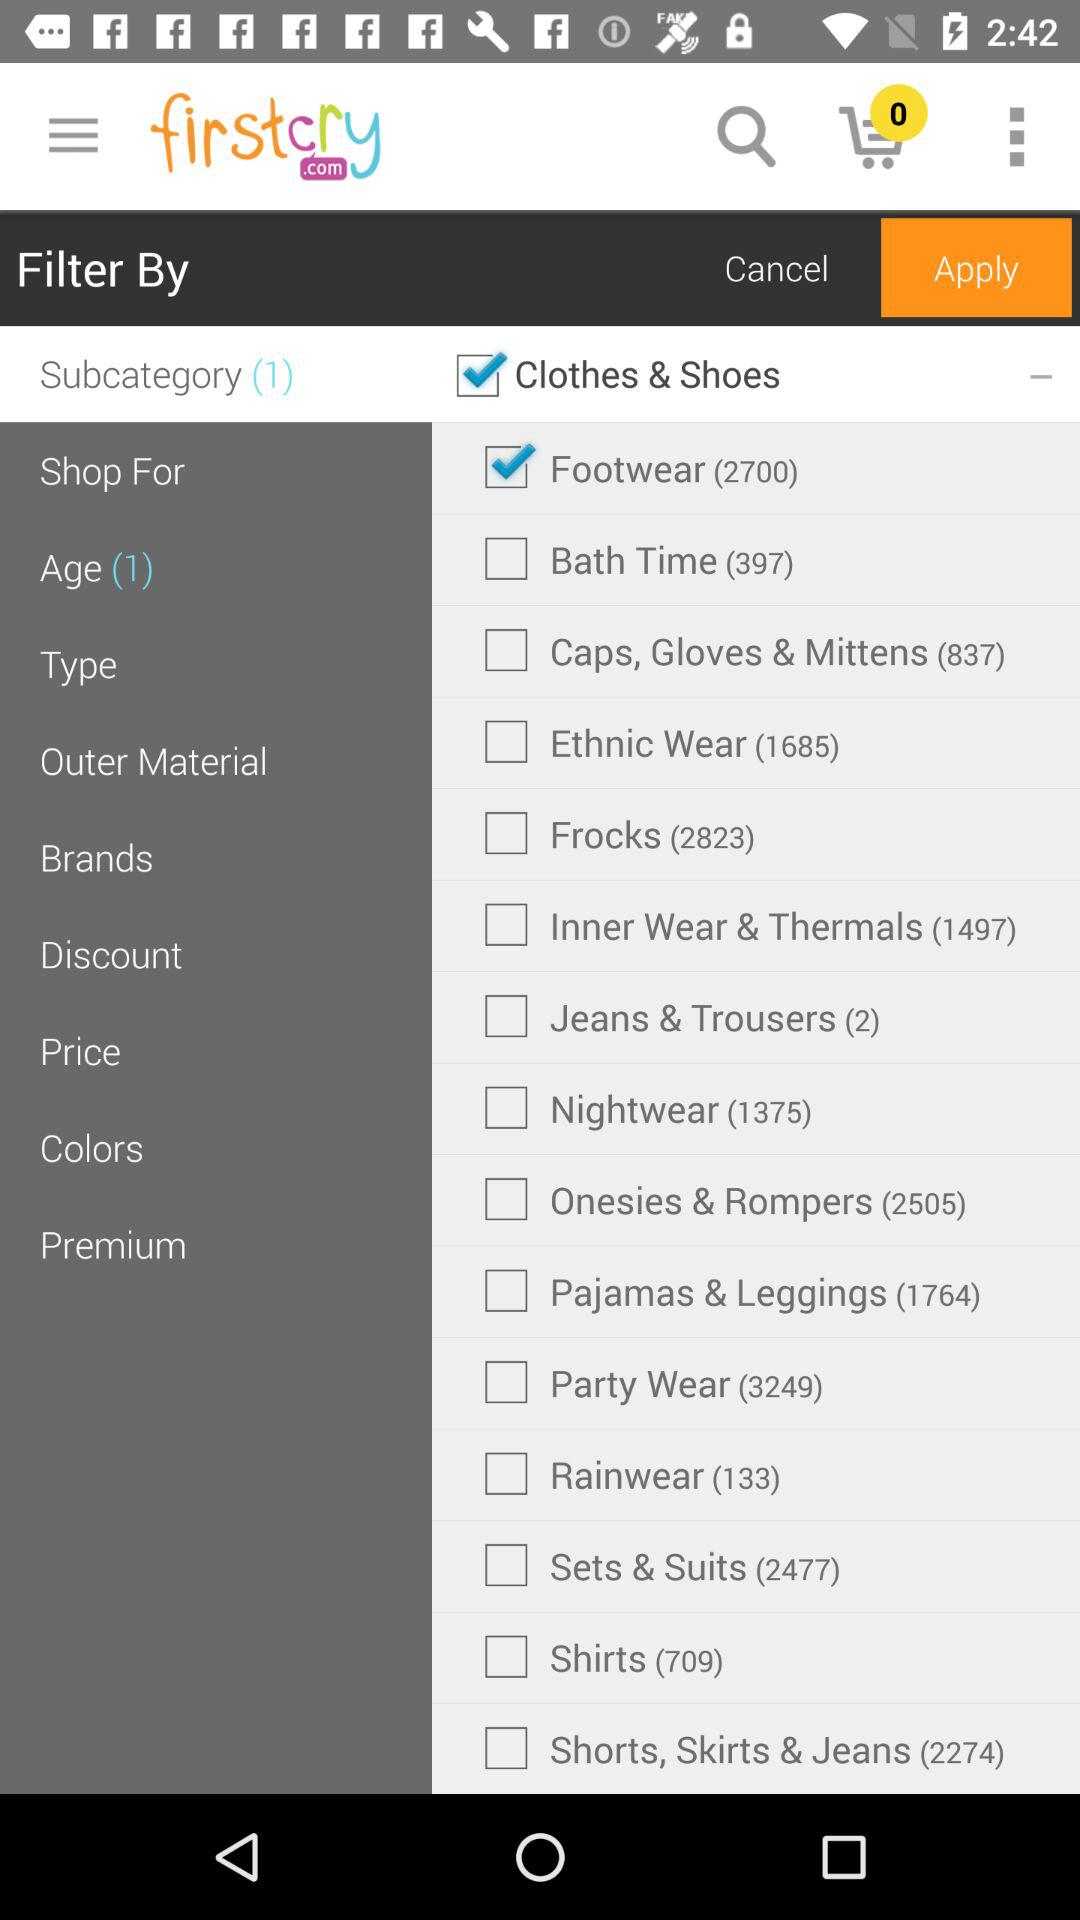What is the selected age?
When the provided information is insufficient, respond with <no answer>. <no answer> 